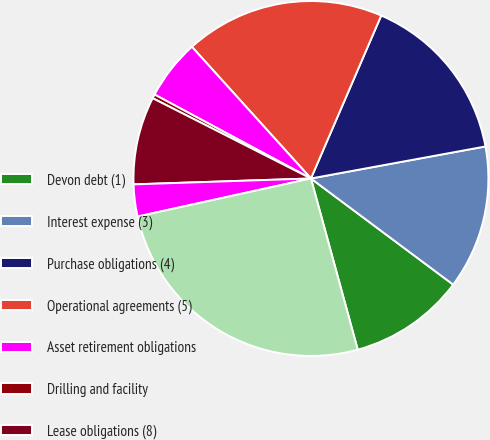Convert chart. <chart><loc_0><loc_0><loc_500><loc_500><pie_chart><fcel>Devon debt (1)<fcel>Interest expense (3)<fcel>Purchase obligations (4)<fcel>Operational agreements (5)<fcel>Asset retirement obligations<fcel>Drilling and facility<fcel>Lease obligations (8)<fcel>Other (9)<fcel>Total (10)<nl><fcel>10.55%<fcel>13.09%<fcel>15.63%<fcel>18.18%<fcel>5.46%<fcel>0.37%<fcel>8.0%<fcel>2.91%<fcel>25.81%<nl></chart> 